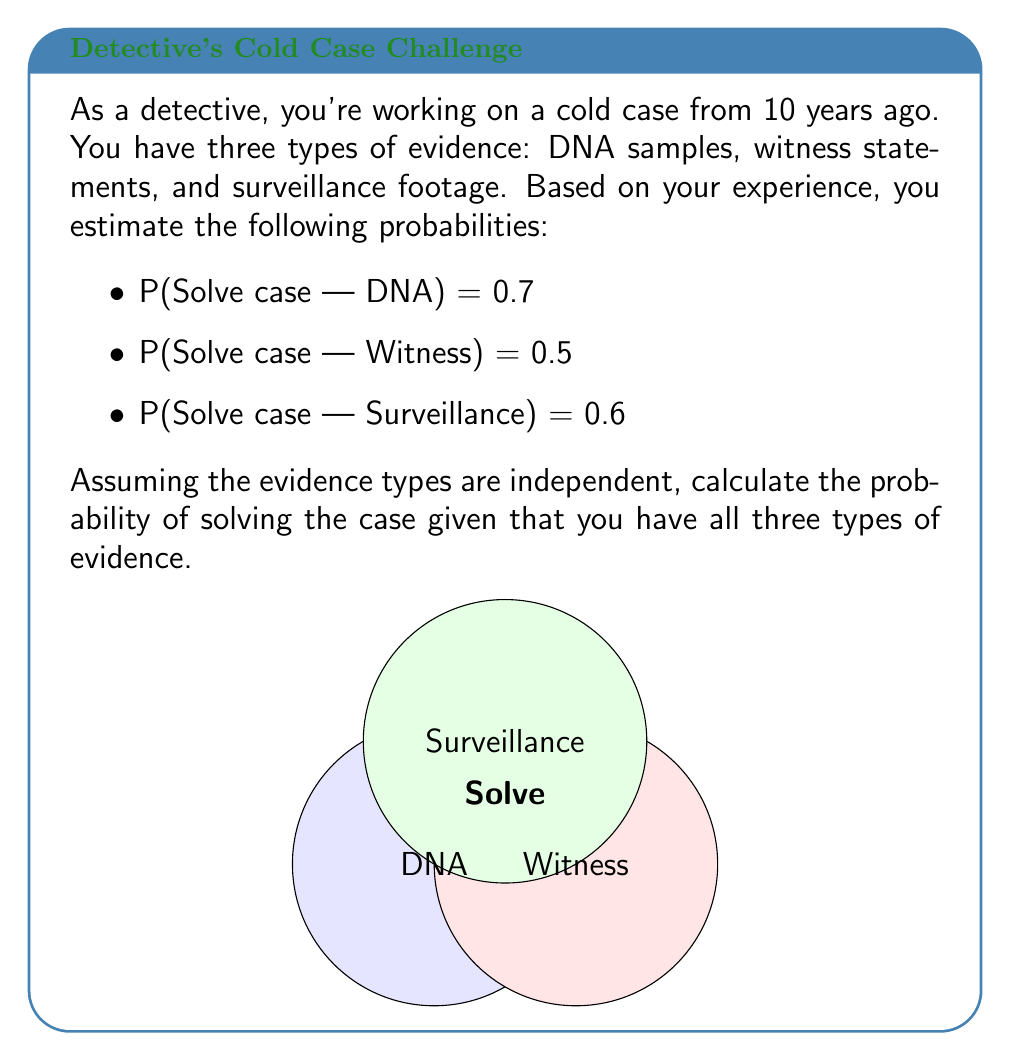Give your solution to this math problem. To solve this problem, we'll use the complement of the probability of not solving the case. Here's the step-by-step solution:

1) First, calculate the probability of not solving the case for each evidence type:
   P(Not solve | DNA) = 1 - 0.7 = 0.3
   P(Not solve | Witness) = 1 - 0.5 = 0.5
   P(Not solve | Surveillance) = 1 - 0.6 = 0.4

2) The probability of not solving the case with all three types of evidence is the product of these probabilities, assuming independence:
   
   $$P(\text{Not solve | All}) = 0.3 \times 0.5 \times 0.4 = 0.06$$

3) Therefore, the probability of solving the case is the complement of this:
   
   $$P(\text{Solve | All}) = 1 - P(\text{Not solve | All}) = 1 - 0.06 = 0.94$$

4) Convert to percentage:
   0.94 × 100% = 94%

This high probability reflects the cumulative strength of having multiple independent pieces of evidence.
Answer: 94% 